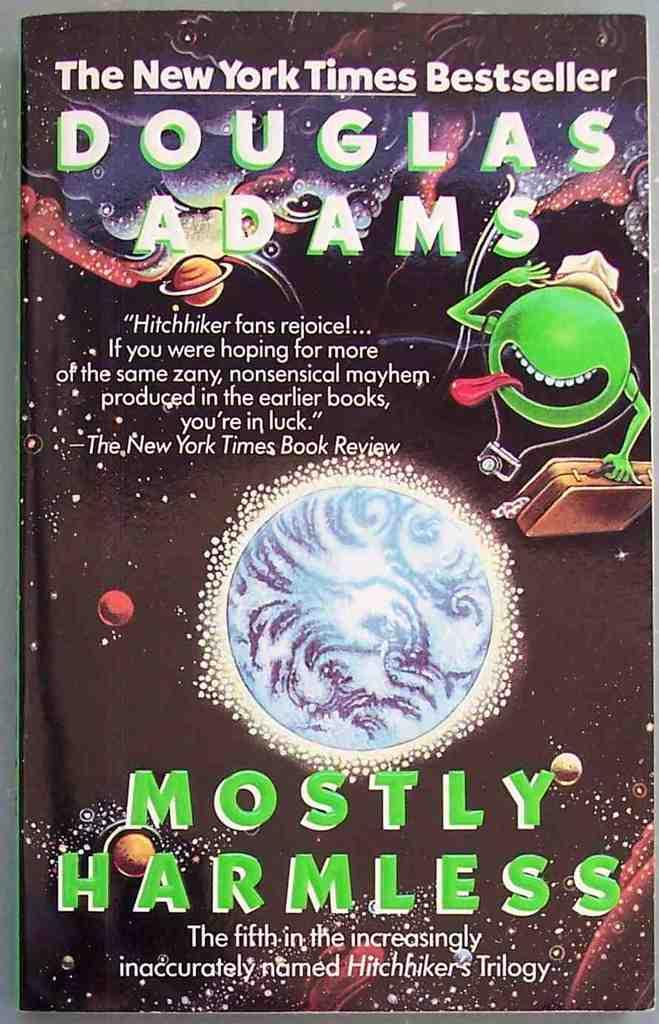<image>
Provide a brief description of the given image. a book cover with a green alien for the book titled Mostly Harmless 